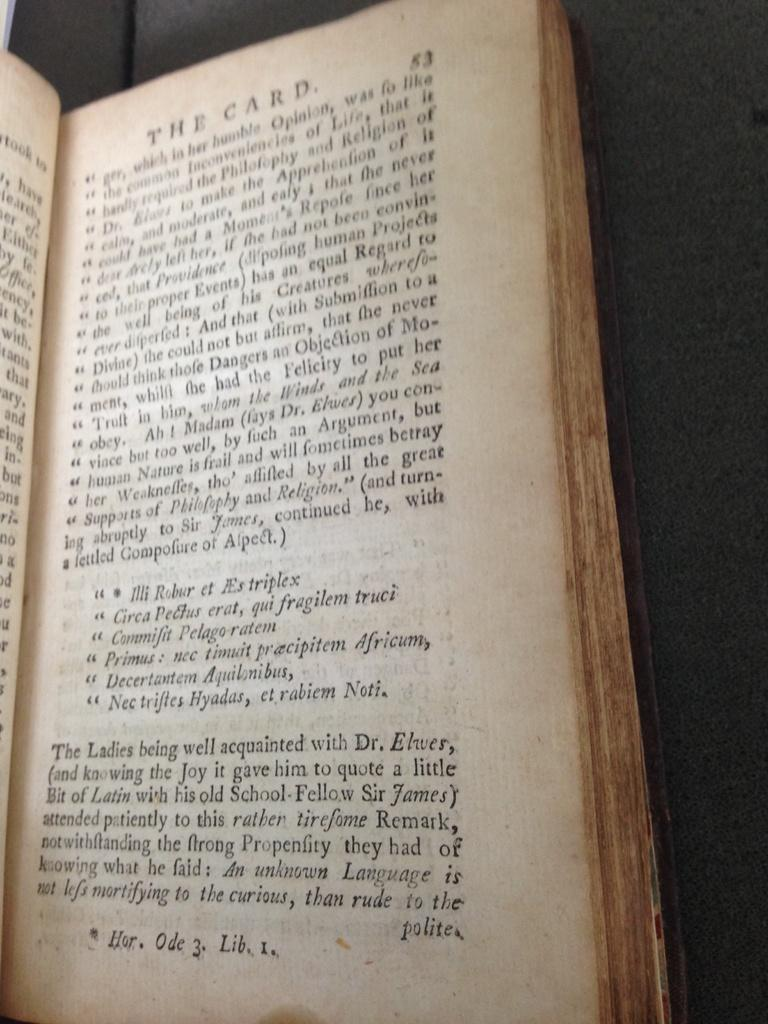Provide a one-sentence caption for the provided image. Book that shows about The Card on page fifty three. 